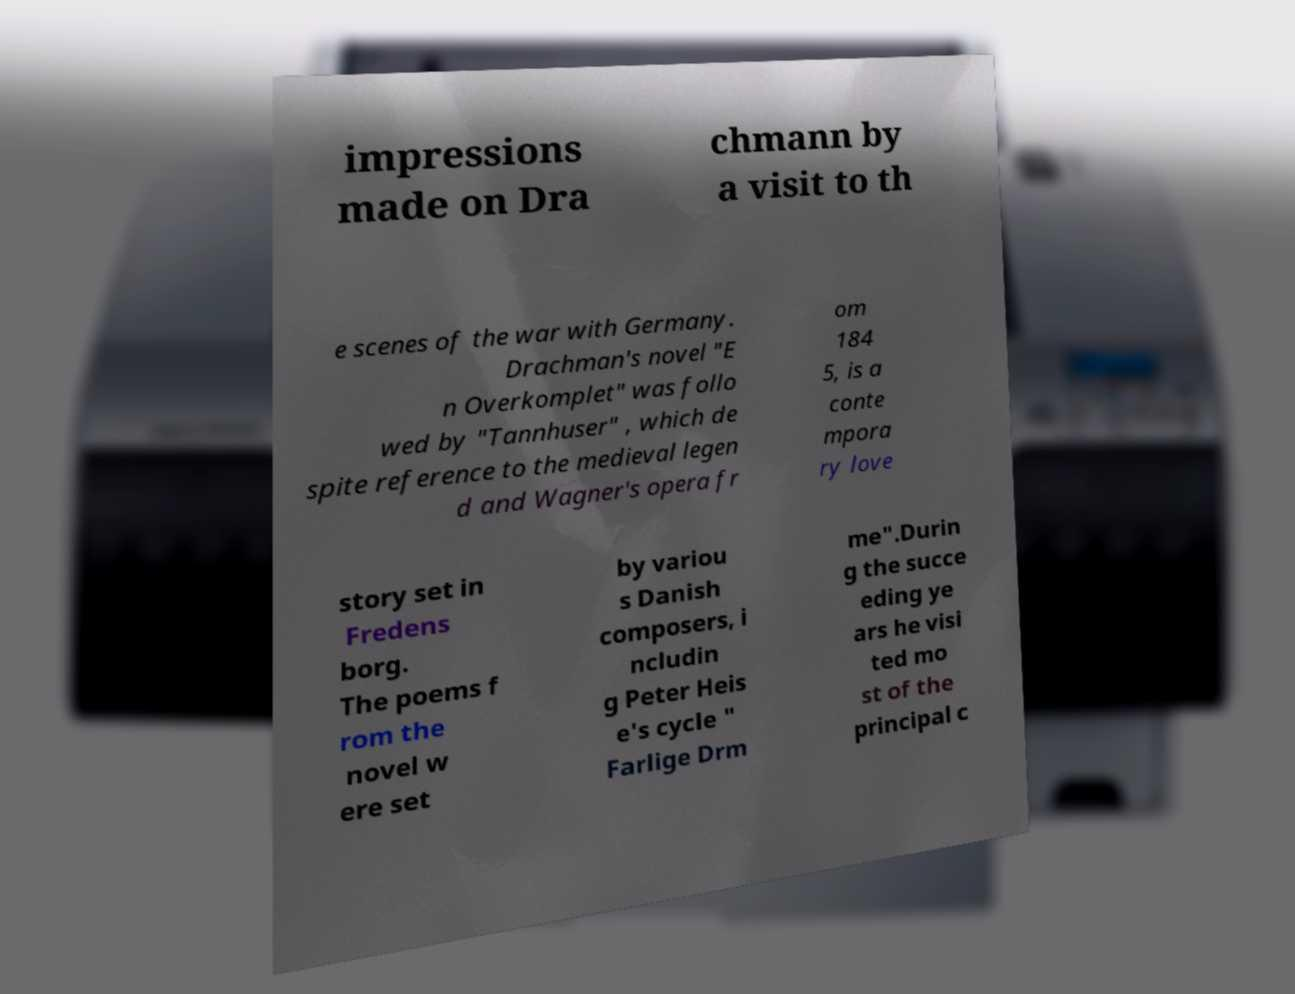Please identify and transcribe the text found in this image. impressions made on Dra chmann by a visit to th e scenes of the war with Germany. Drachman's novel "E n Overkomplet" was follo wed by "Tannhuser" , which de spite reference to the medieval legen d and Wagner's opera fr om 184 5, is a conte mpora ry love story set in Fredens borg. The poems f rom the novel w ere set by variou s Danish composers, i ncludin g Peter Heis e's cycle " Farlige Drm me".Durin g the succe eding ye ars he visi ted mo st of the principal c 